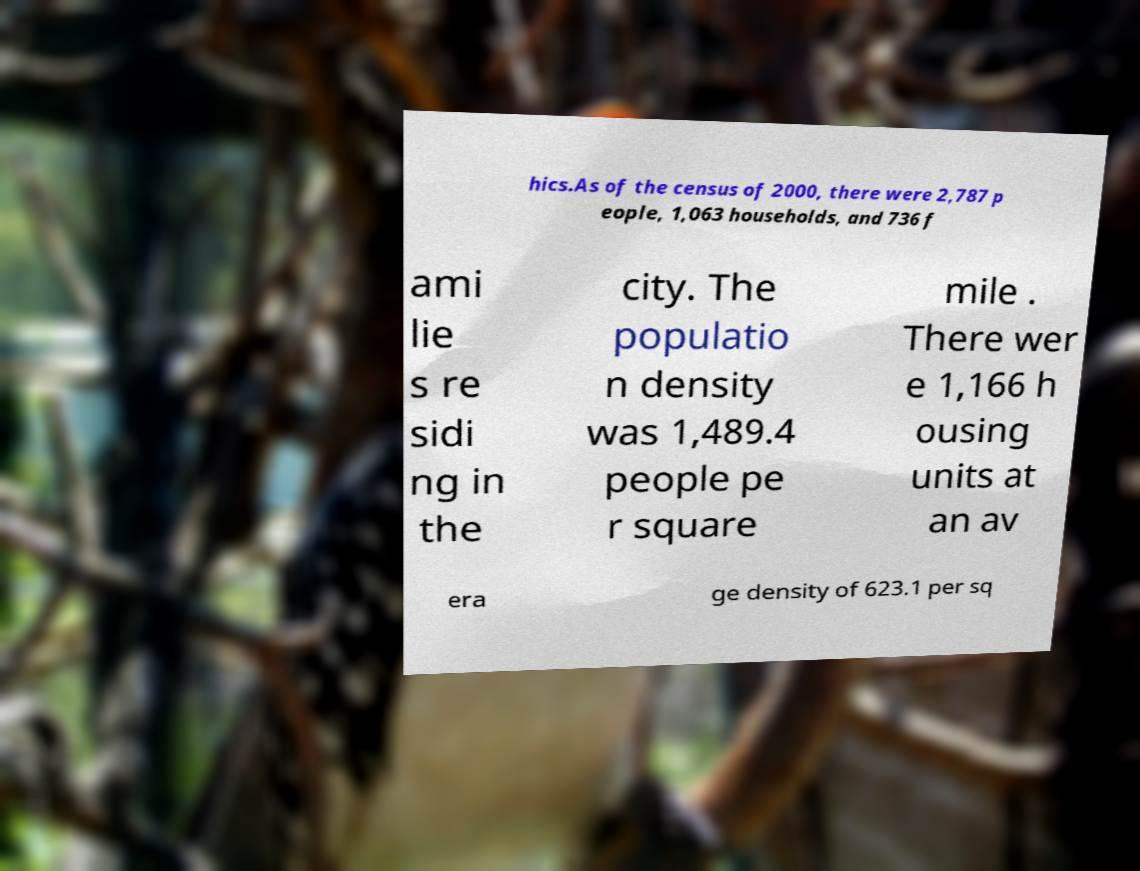For documentation purposes, I need the text within this image transcribed. Could you provide that? hics.As of the census of 2000, there were 2,787 p eople, 1,063 households, and 736 f ami lie s re sidi ng in the city. The populatio n density was 1,489.4 people pe r square mile . There wer e 1,166 h ousing units at an av era ge density of 623.1 per sq 